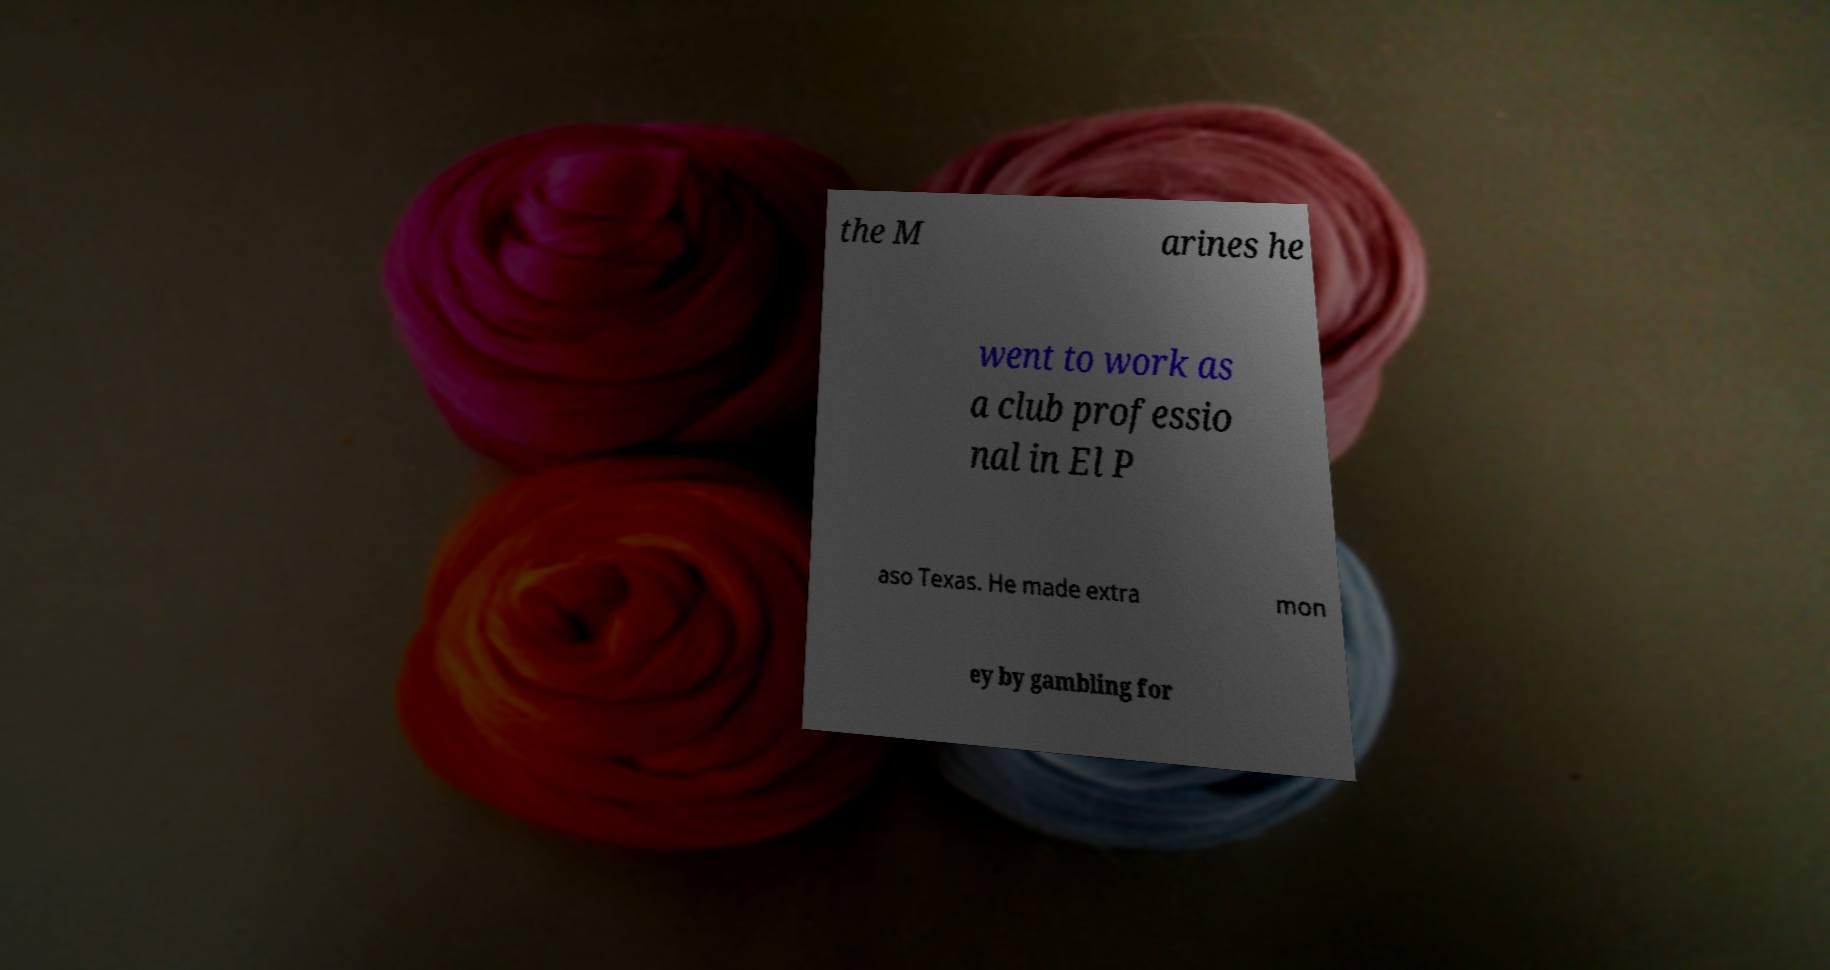Could you assist in decoding the text presented in this image and type it out clearly? the M arines he went to work as a club professio nal in El P aso Texas. He made extra mon ey by gambling for 